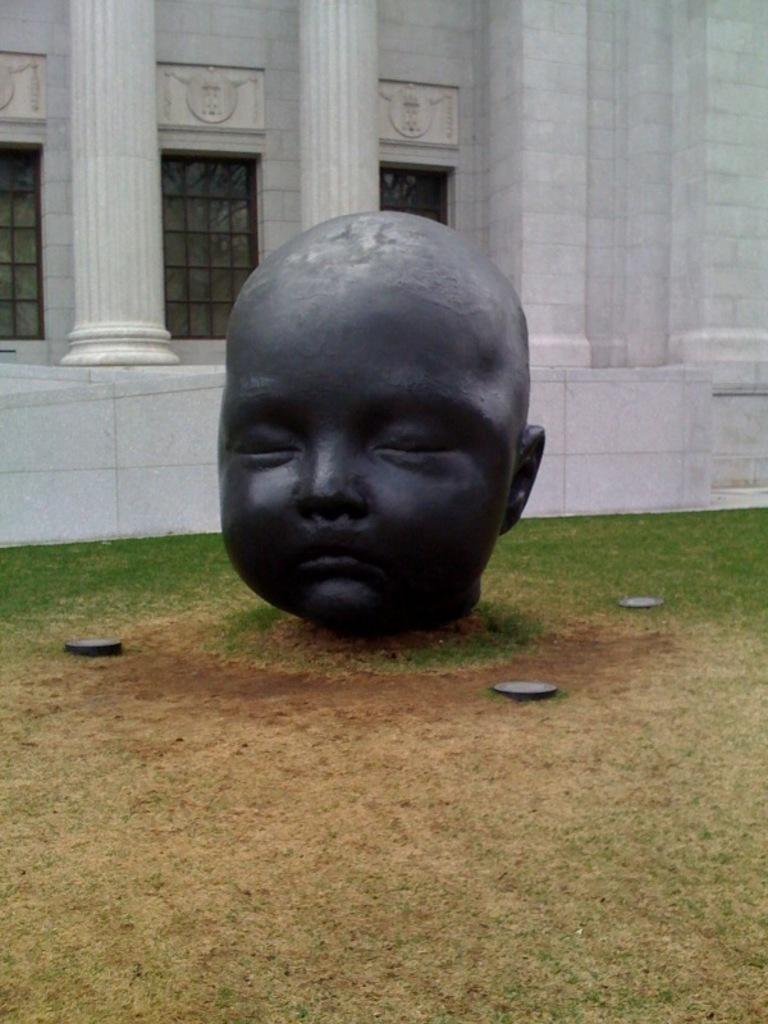What is the main subject in the middle of the picture? There is a statue in the middle of the picture. What can be seen behind the statue? There is a white building behind the statue. What architectural features does the building have? The building has pillars and windows. What type of ground is visible at the bottom of the picture? There is grass at the bottom of the picture. What type of hole can be seen in the statue in the image? There is no hole present in the statue in the image. What type of office is located inside the building in the image? The image does not show the interior of the building, so it is not possible to determine if there is an office inside. 